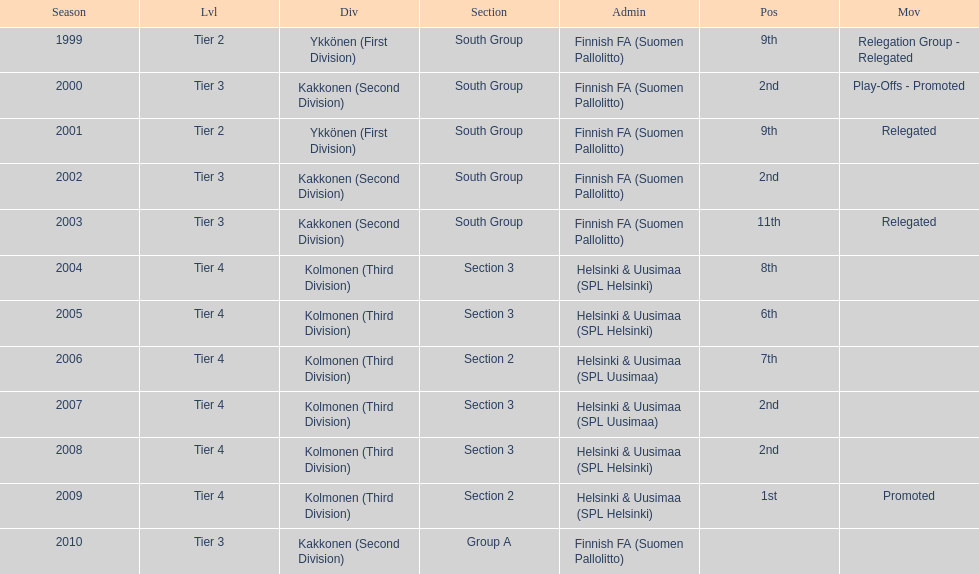What position did this team get after getting 9th place in 1999? 2nd. 